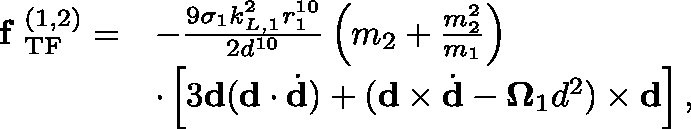<formula> <loc_0><loc_0><loc_500><loc_500>\begin{array} { r l } { f _ { T F } ^ { ( 1 , 2 ) } = } & { - \frac { 9 \sigma _ { 1 } k _ { L , 1 } ^ { 2 } r _ { 1 } ^ { 1 0 } } { 2 d ^ { 1 0 } } \left ( m _ { 2 } + \frac { m _ { 2 } ^ { 2 } } { m _ { 1 } } \right ) } \\ & { \cdot \left [ 3 d ( d \cdot \dot { d } ) + ( d \times \dot { d } - \Omega _ { 1 } d ^ { 2 } ) \times d \right ] , } \end{array}</formula> 